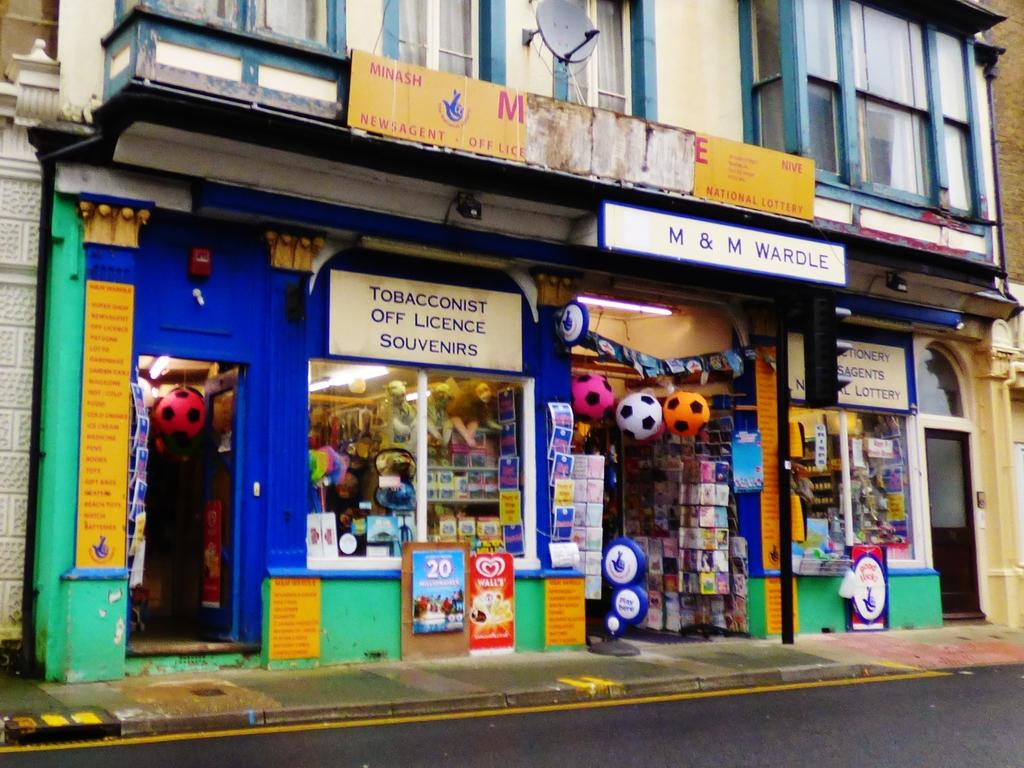<image>
Give a short and clear explanation of the subsequent image. A store called M & M Wardle with a sign that says Tobacconist Off Licence Souvenirs. 